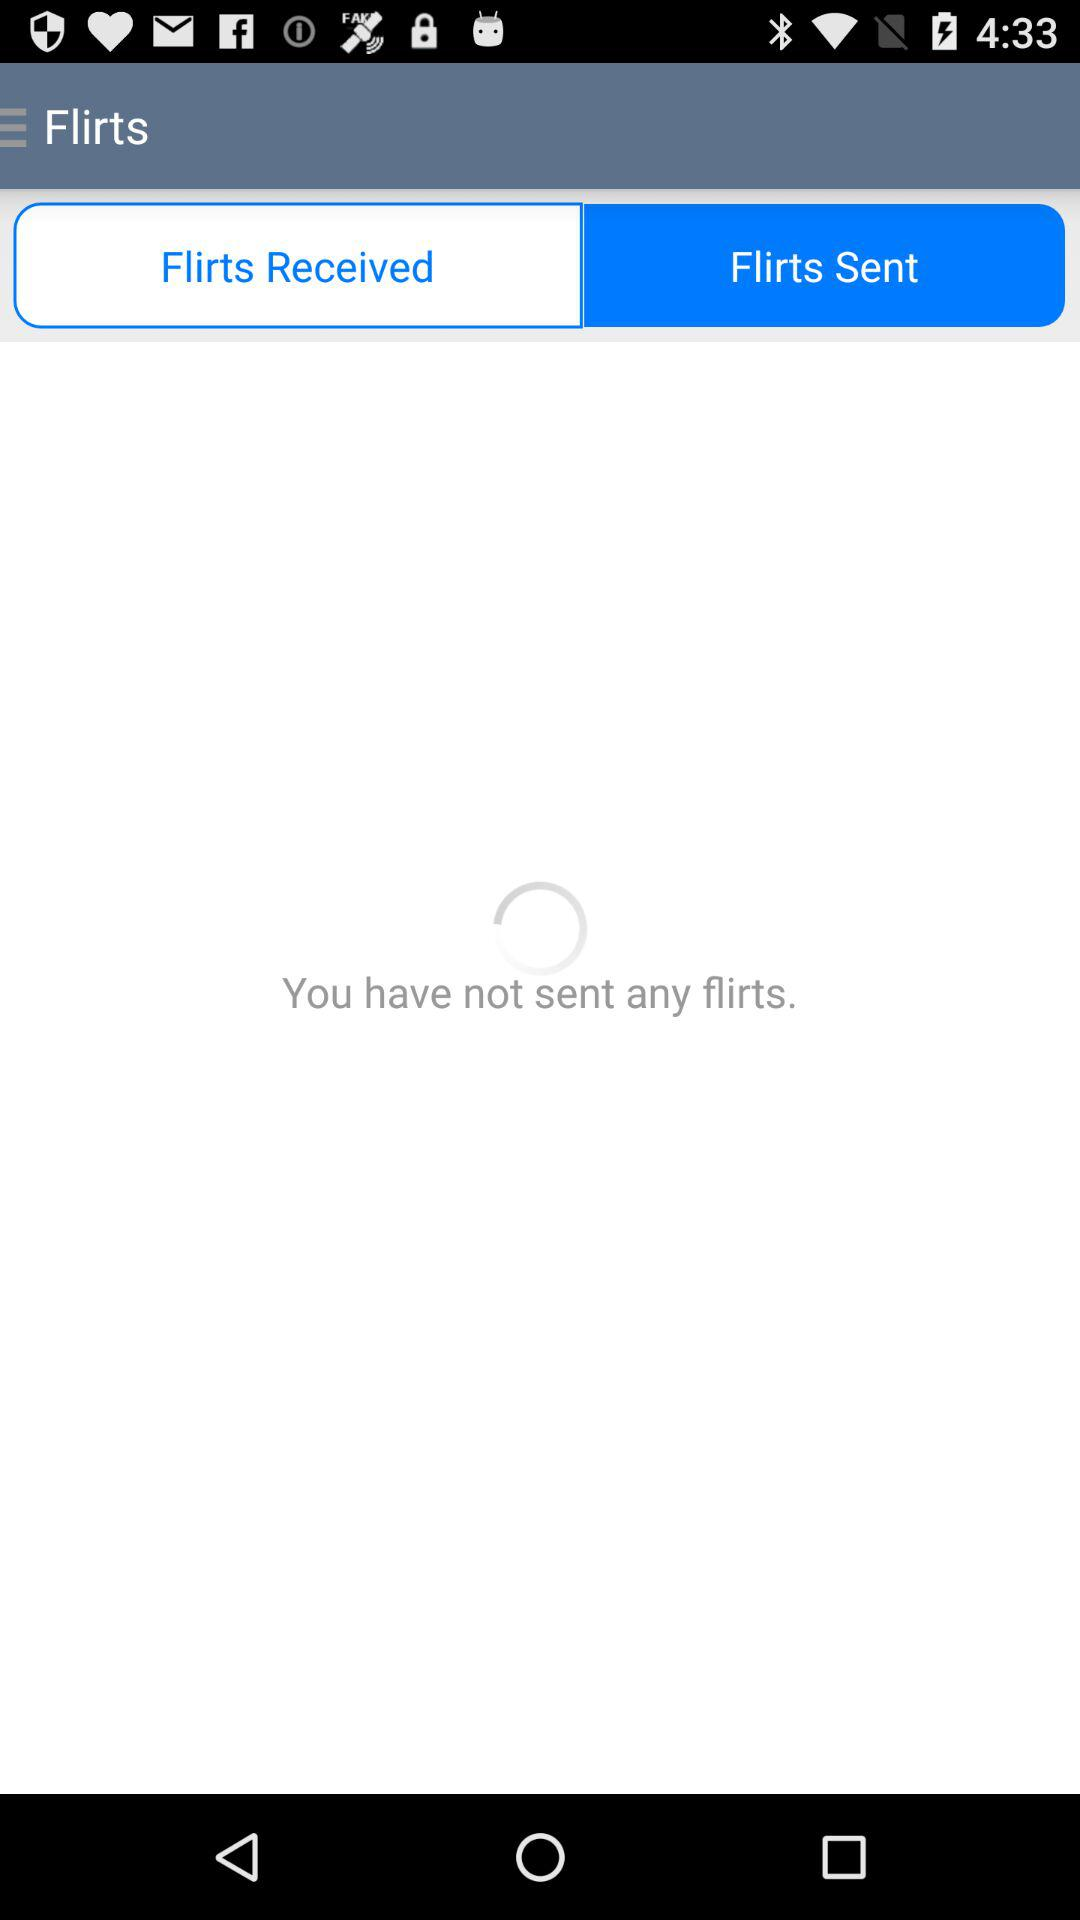Which tab is selected? The selected tab is "Flirts Sent". 